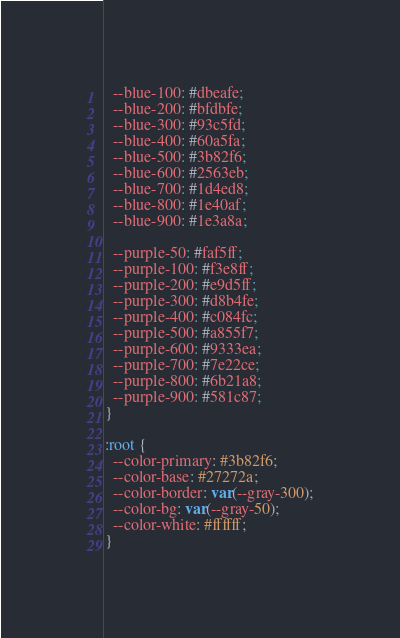<code> <loc_0><loc_0><loc_500><loc_500><_CSS_>  --blue-100: #dbeafe;
  --blue-200: #bfdbfe;
  --blue-300: #93c5fd;
  --blue-400: #60a5fa;
  --blue-500: #3b82f6;
  --blue-600: #2563eb;
  --blue-700: #1d4ed8;
  --blue-800: #1e40af;
  --blue-900: #1e3a8a;

  --purple-50: #faf5ff;
  --purple-100: #f3e8ff;
  --purple-200: #e9d5ff;
  --purple-300: #d8b4fe;
  --purple-400: #c084fc;
  --purple-500: #a855f7;
  --purple-600: #9333ea;
  --purple-700: #7e22ce;
  --purple-800: #6b21a8;
  --purple-900: #581c87;
}

:root {
  --color-primary: #3b82f6;
  --color-base: #27272a;
  --color-border: var(--gray-300);
  --color-bg: var(--gray-50);
  --color-white: #ffffff;
}
</code> 